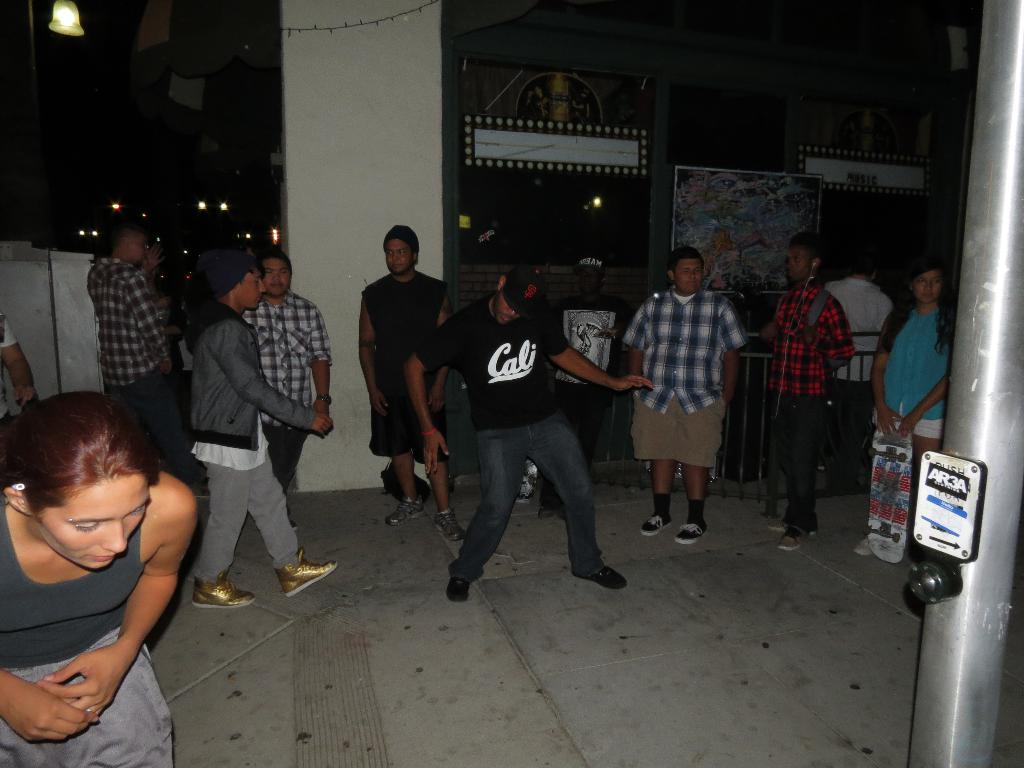What are the people in the image doing? There are people standing, a man is walking, and another man is dancing in the image. Can you describe the woman in the image? The woman is holding a skateboard in the image. What objects can be seen in the background of the image? There is a pole and a frame on the wall in the image. What type of sheet is being used to push the man walking in the image? There is no sheet present in the image, and the man is walking on his own without any assistance. 